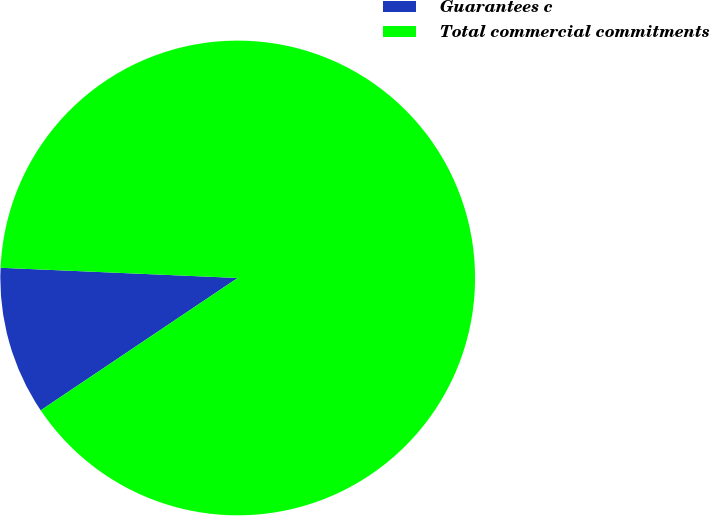Convert chart to OTSL. <chart><loc_0><loc_0><loc_500><loc_500><pie_chart><fcel>Guarantees c<fcel>Total commercial commitments<nl><fcel>10.1%<fcel>89.9%<nl></chart> 